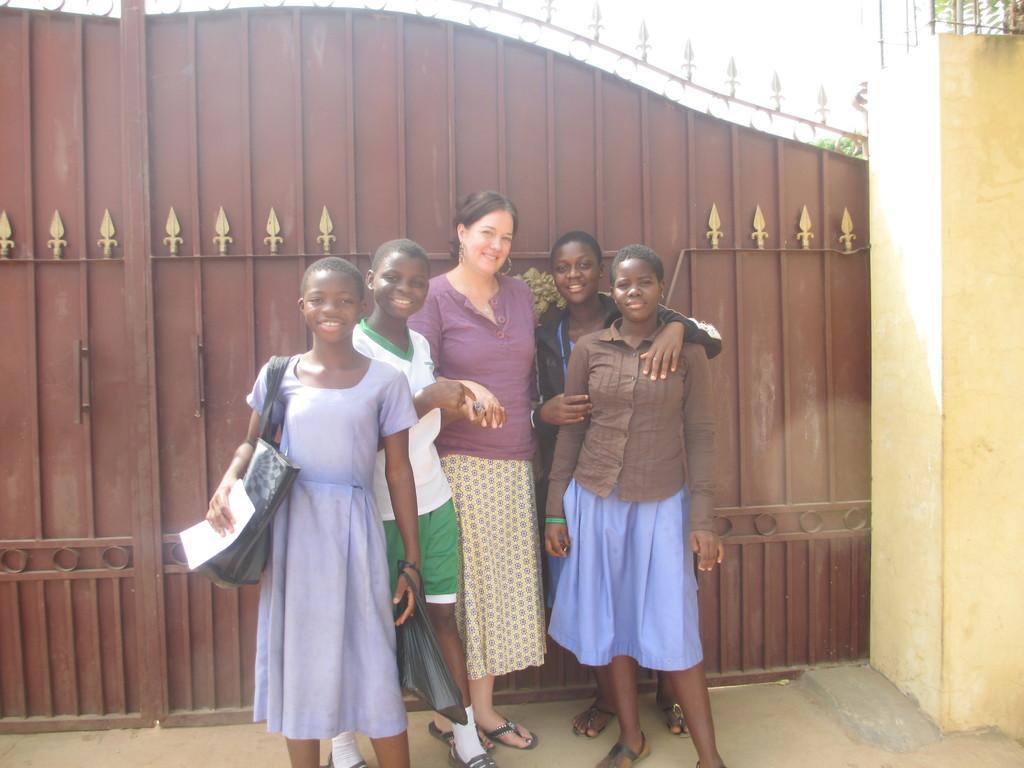How would you summarize this image in a sentence or two? In this image we can see women standing on the floor and there is a gate in the background. 